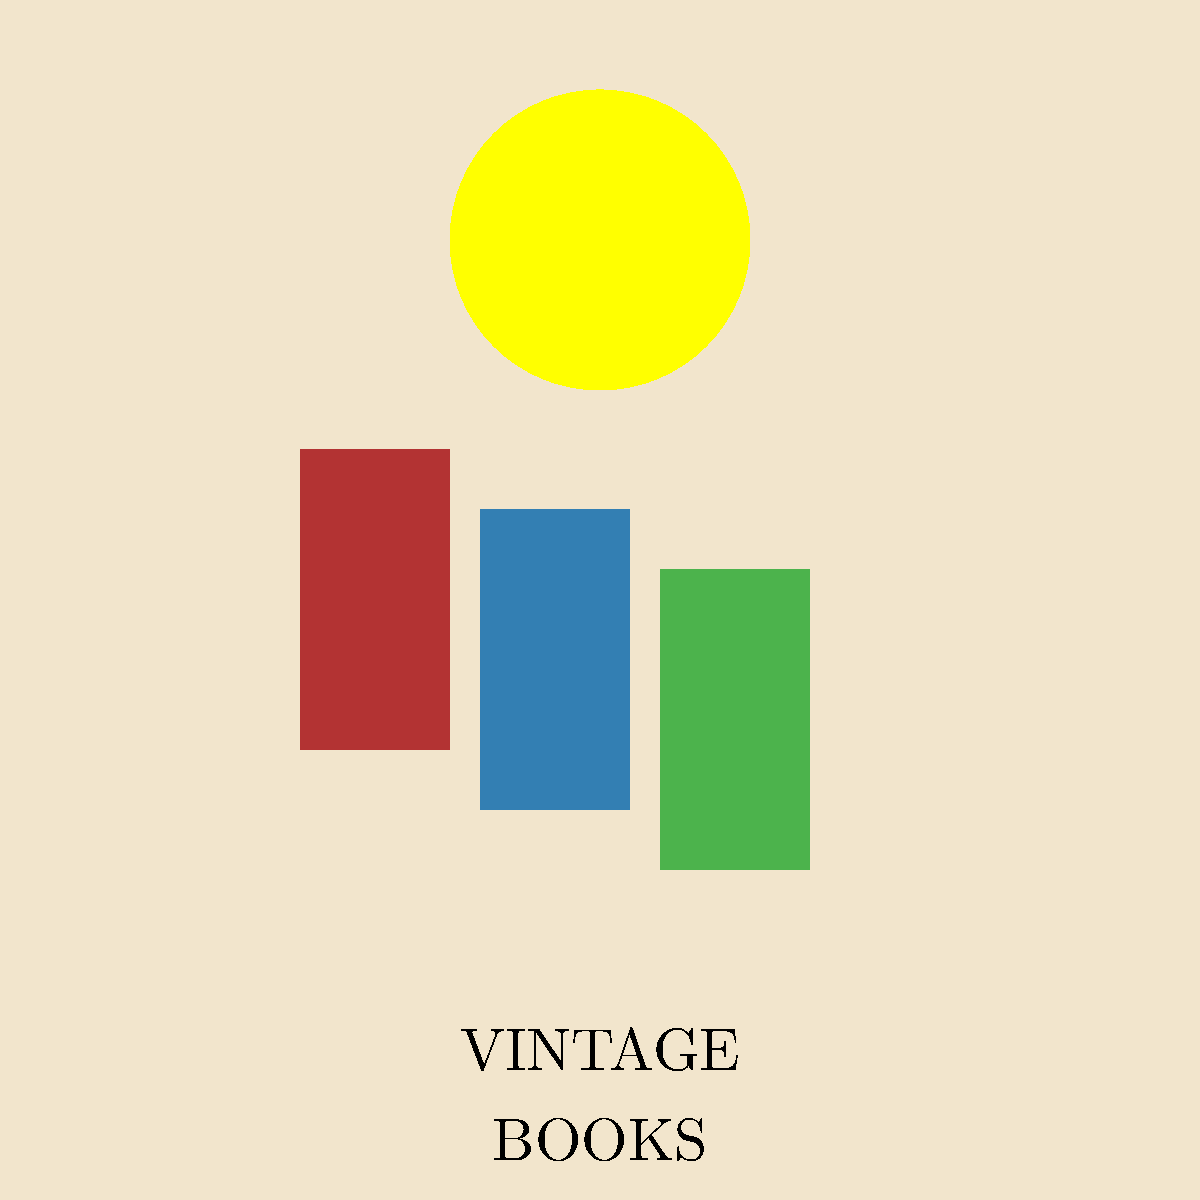Analyze the symbolism in this vintage-style poster design for a bookstore. What does the prominent sun symbol likely represent in the context of books and knowledge, and how does its positioning contribute to the overall message? To interpret the symbolism in this vintage poster design, let's break it down step-by-step:

1. Sun symbol:
   - The sun is a prominent feature in the upper part of the poster.
   - In many cultures, the sun symbolizes enlightenment, knowledge, and wisdom.
   - Its circular shape can represent completeness or the cycle of learning.

2. Positioning of the sun:
   - The sun is placed above the books, suggesting it illuminates or shines upon them.
   - This positioning creates a visual hierarchy, emphasizing the sun's importance.

3. Books:
   - The simplified book silhouettes represent knowledge, stories, and information.
   - Their varied colors suggest diversity in content or genres.

4. Relationship between sun and books:
   - The sun's rays (implied by its presence) metaphorically shine on the books below.
   - This arrangement suggests that reading and knowledge lead to enlightenment or illuminate one's mind.

5. Vintage style:
   - The muted color palette and simplified shapes evoke a sense of nostalgia and timelessness.
   - This style reinforces the idea of enduring wisdom found in books.

6. Overall composition:
   - The centrality of the sun and its position above the books creates a visual metaphor for the transformative power of reading.
   - The design implies that books are a source of illumination, both literally and figuratively.

Given these elements, the sun likely represents enlightenment or knowledge gained through reading. Its positioning above the books suggests that this enlightenment is attainable through the act of reading and learning from books.
Answer: The sun symbolizes enlightenment through reading, with its position above the books emphasizing knowledge's transformative power. 